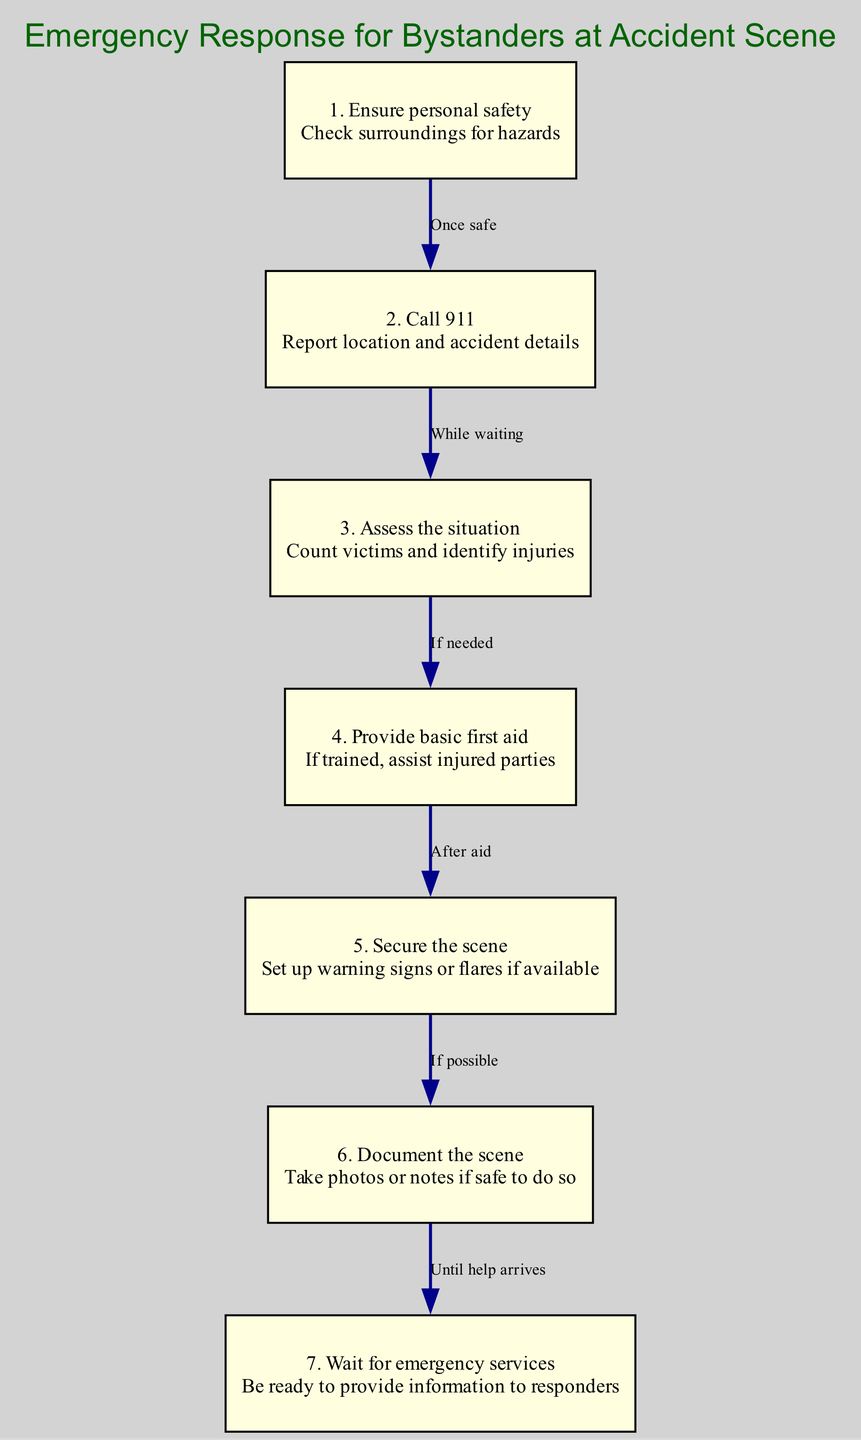What is the first step in the emergency response procedure? The first step is to "Ensure personal safety," which emphasizes checking the surroundings for any hazards before taking further action.
Answer: Ensure personal safety How many steps are in the emergency response diagram? There are a total of seven steps listed in the diagram for proper emergency response at an accident scene.
Answer: Seven What action should be taken after ensuring personal safety? After ensuring personal safety, the next action is to "Call 911" to report the location and details of the accident.
Answer: Call 911 Which step follows assessing the situation? The step that follows "Assess the situation" is "Provide basic first aid," indicating that aid is provided if needed based on the assessment.
Answer: Provide basic first aid What is the connection type between step 5 and step 6? The connection type is "If possible," which suggests that securing the scene with warning signs or flares leads to documenting the scene if it is feasible.
Answer: If possible What must you do after providing basic first aid? After providing basic first aid, the next step is to "Secure the scene" by setting up warning signs or flares if they are available.
Answer: Secure the scene During which step should you take photos or notes? Photos or notes should be documented during the "Document the scene" step, which comes after securing the scene.
Answer: Document the scene What do you need to be ready for while waiting for emergency services? While waiting for emergency services, you need to be ready to "provide information to responders" about the situation.
Answer: Provide information to responders 